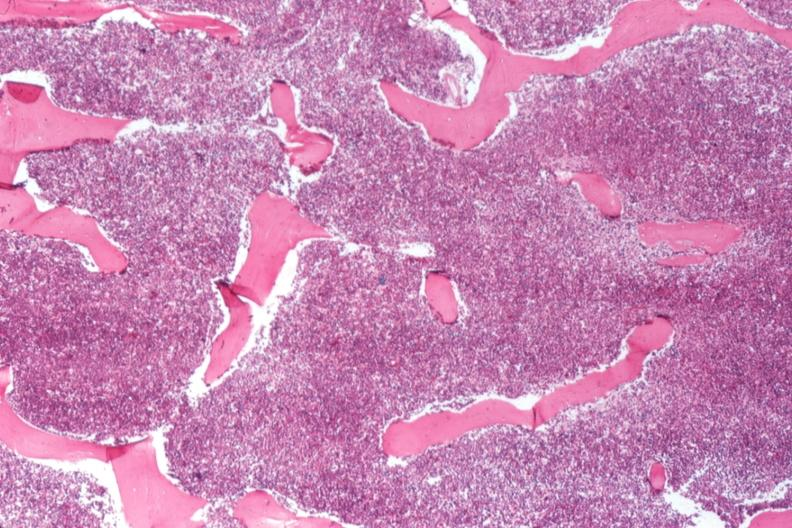s no tissue recognizable as ovary present?
Answer the question using a single word or phrase. No 